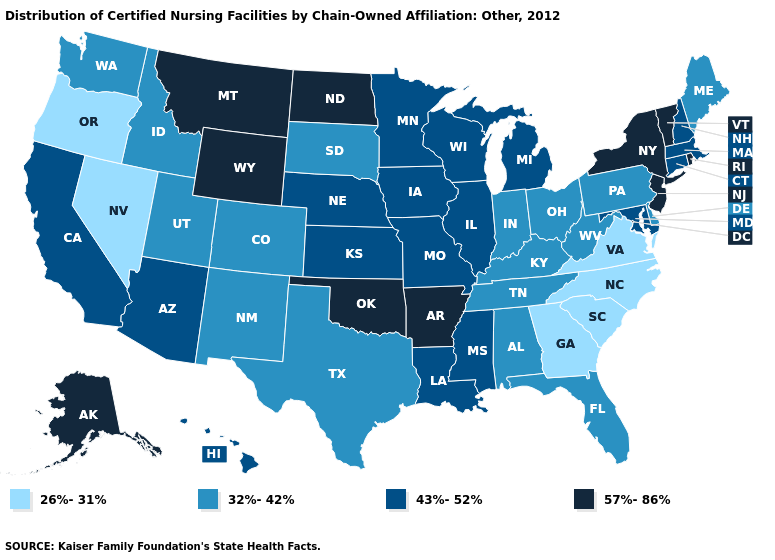Name the states that have a value in the range 32%-42%?
Quick response, please. Alabama, Colorado, Delaware, Florida, Idaho, Indiana, Kentucky, Maine, New Mexico, Ohio, Pennsylvania, South Dakota, Tennessee, Texas, Utah, Washington, West Virginia. Which states have the highest value in the USA?
Give a very brief answer. Alaska, Arkansas, Montana, New Jersey, New York, North Dakota, Oklahoma, Rhode Island, Vermont, Wyoming. Among the states that border West Virginia , does Maryland have the lowest value?
Answer briefly. No. Among the states that border Maryland , does Virginia have the highest value?
Short answer required. No. Does California have the highest value in the USA?
Keep it brief. No. What is the highest value in states that border Mississippi?
Keep it brief. 57%-86%. What is the value of New Hampshire?
Keep it brief. 43%-52%. What is the value of Arkansas?
Write a very short answer. 57%-86%. What is the lowest value in the USA?
Concise answer only. 26%-31%. Among the states that border Illinois , which have the highest value?
Concise answer only. Iowa, Missouri, Wisconsin. Does New York have the lowest value in the USA?
Quick response, please. No. Does South Carolina have the lowest value in the USA?
Give a very brief answer. Yes. Which states have the lowest value in the USA?
Concise answer only. Georgia, Nevada, North Carolina, Oregon, South Carolina, Virginia. What is the lowest value in the USA?
Concise answer only. 26%-31%. Name the states that have a value in the range 26%-31%?
Concise answer only. Georgia, Nevada, North Carolina, Oregon, South Carolina, Virginia. 